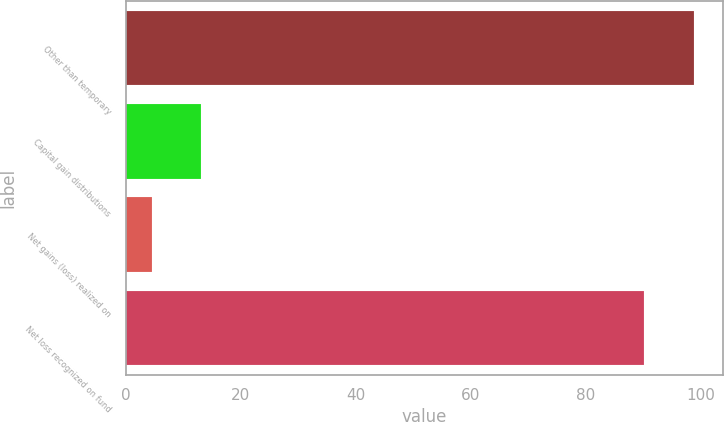Convert chart to OTSL. <chart><loc_0><loc_0><loc_500><loc_500><bar_chart><fcel>Other than temporary<fcel>Capital gain distributions<fcel>Net gains (loss) realized on<fcel>Net loss recognized on fund<nl><fcel>98.88<fcel>13.18<fcel>4.5<fcel>90.2<nl></chart> 